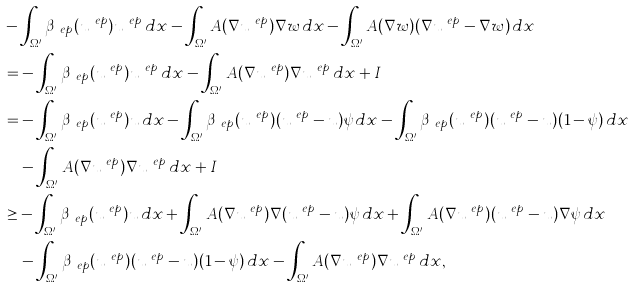<formula> <loc_0><loc_0><loc_500><loc_500>& - \int _ { \Omega ^ { \prime } } \beta _ { \ e p } ( u ^ { \ e p } ) u ^ { \ e p } \, d x - \int _ { \Omega ^ { \prime } } A ( \nabla u ^ { \ e p } ) \nabla w \, d x - \int _ { \Omega ^ { \prime } } A ( \nabla w ) ( \nabla u ^ { \ e p } - \nabla w ) \, d x \\ & = - \int _ { \Omega ^ { \prime } } \beta _ { \ e p } ( u ^ { \ e p } ) u ^ { \ e p } \, d x - \int _ { \Omega ^ { \prime } } A ( \nabla u ^ { \ e p } ) \nabla u ^ { \ e p } \, d x + I \\ & = - \int _ { \Omega ^ { \prime } } \beta _ { \ e p } ( u ^ { \ e p } ) u \, d x - \int _ { \Omega ^ { \prime } } \beta _ { \ e p } ( u ^ { \ e p } ) ( u ^ { \ e p } - u ) \psi \, d x - \int _ { \Omega ^ { \prime } } \beta _ { \ e p } ( u ^ { \ e p } ) ( u ^ { \ e p } - u ) ( 1 - \psi ) \, d x \\ & \quad - \int _ { \Omega ^ { \prime } } A ( \nabla u ^ { \ e p } ) \nabla u ^ { \ e p } \, d x + I \\ & \geq - \int _ { \Omega ^ { \prime } } \beta _ { \ e p } ( u ^ { \ e p } ) u \, d x + \int _ { \Omega ^ { \prime } } A ( \nabla u ^ { \ e p } ) \nabla ( u ^ { \ e p } - u ) \psi \, d x + \int _ { \Omega ^ { \prime } } A ( \nabla u ^ { \ e p } ) ( u ^ { \ e p } - u ) \nabla \psi \, d x \\ & \ \ \ - \int _ { \Omega ^ { \prime } } \beta _ { \ e p } ( u ^ { \ e p } ) ( u ^ { \ e p } - u ) ( 1 - \psi ) \, d x - \int _ { \Omega ^ { \prime } } A ( \nabla u ^ { \ e p } ) \nabla u ^ { \ e p } \, d x ,</formula> 